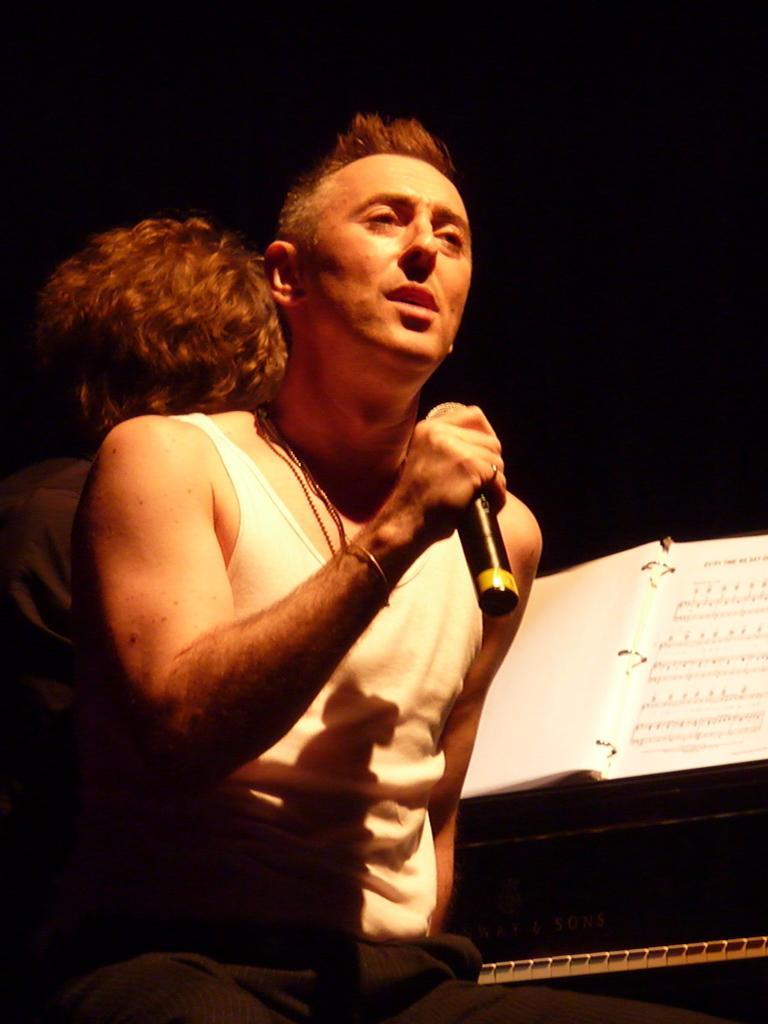Could you give a brief overview of what you see in this image? Here we see a man performing with the help of a microphone and a man playing an instrument. 